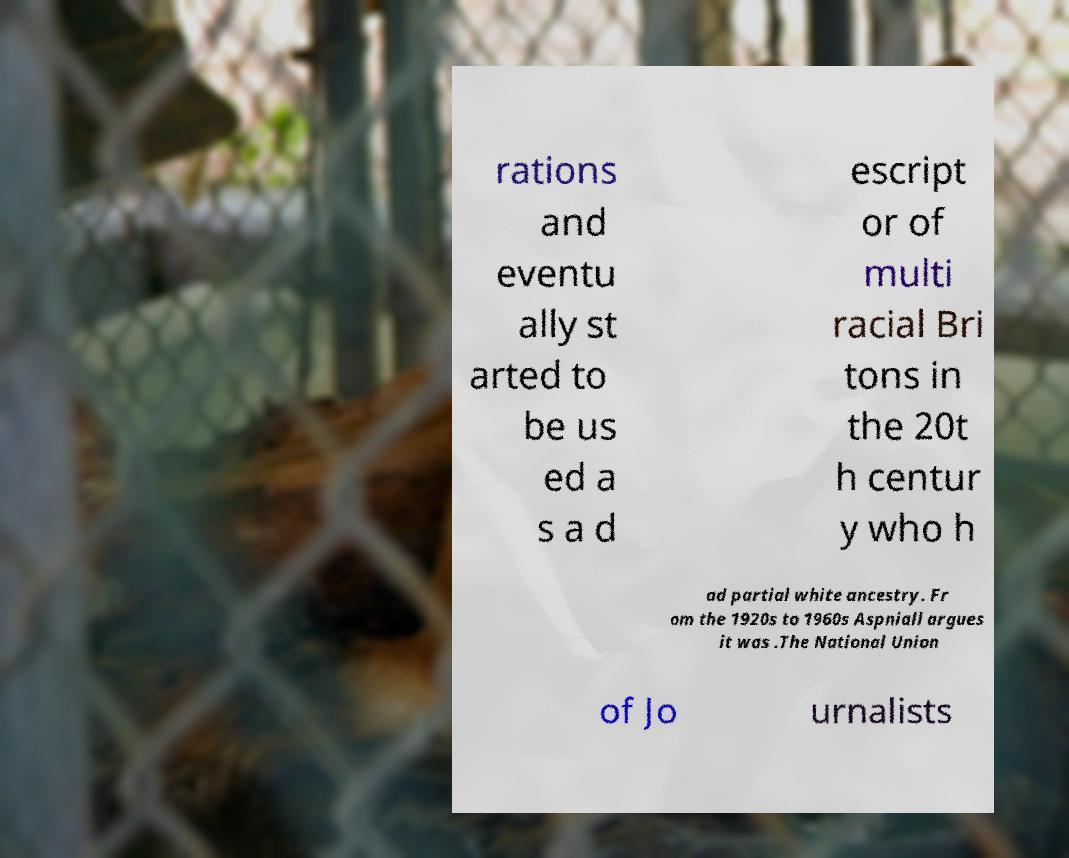Can you read and provide the text displayed in the image?This photo seems to have some interesting text. Can you extract and type it out for me? rations and eventu ally st arted to be us ed a s a d escript or of multi racial Bri tons in the 20t h centur y who h ad partial white ancestry. Fr om the 1920s to 1960s Aspniall argues it was .The National Union of Jo urnalists 